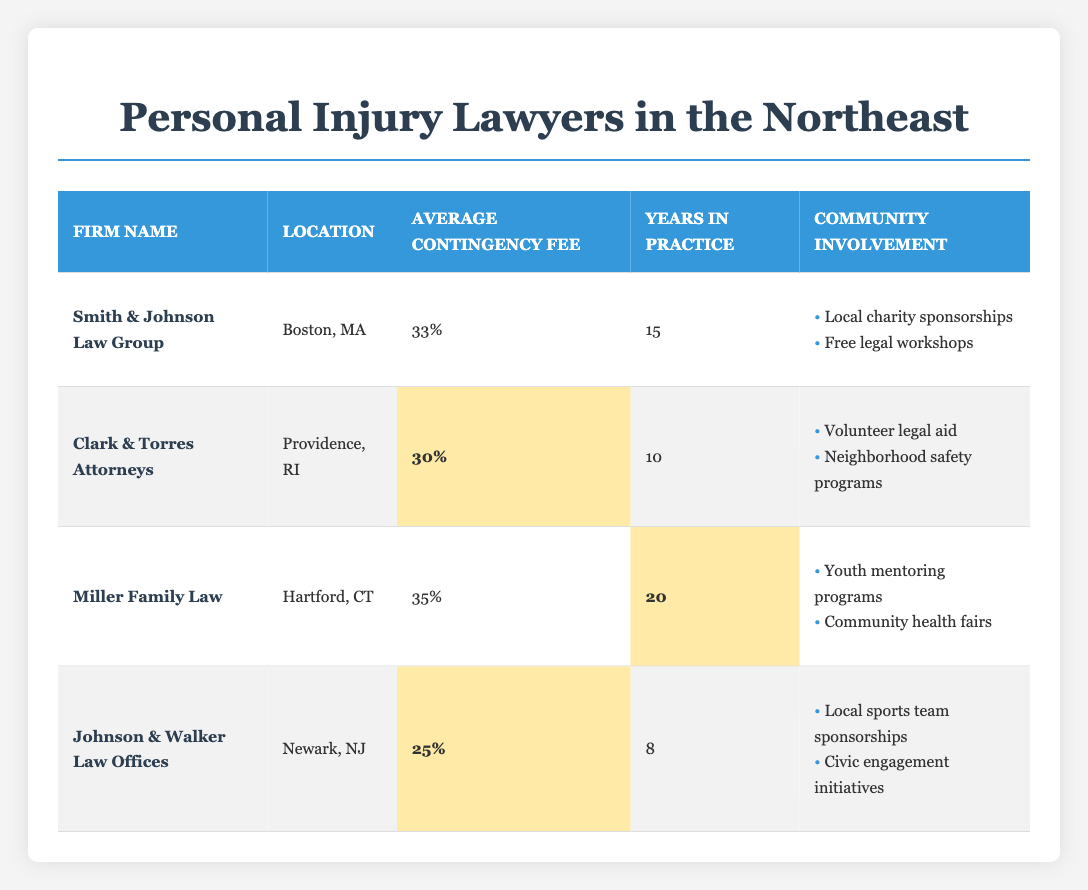What is the average contingency fee among the law firms listed? To find the average contingency fee, we need to add the contingency fees of all firms. They are 33%, 30%, 35%, and 25%. The sum is 33 + 30 + 35 + 25 = 123%. There are 4 firms, so we divide the total by 4: 123% / 4 = 30.75%.
Answer: 30.75% Which firm has the highest average contingency fee? The contingency fees listed are 33%, 30%, 35%, and 25%. The highest of these is 35%, which belongs to Miller Family Law.
Answer: Miller Family Law Does Johnson & Walker Law Offices have the least amount of years in practice among the firms listed? The years in practice for each firm are 15, 10, 20, and 8. Johnson & Walker Law Offices has 8 years, which is indeed the least among the listed firms.
Answer: Yes How many community involvement activities are listed for Clark & Torres Attorneys? Clark & Torres Attorneys has 2 community involvement activities, which are "Volunteer legal aid" and "Neighborhood safety programs".
Answer: 2 Is there a firm with a contingency fee lower than 30%? The listed contingency fees are 33%, 30%, 35%, and 25%. Since 25% is lower than 30%, Johnson & Walker Law Offices has a lower fee.
Answer: Yes What are the community involvement activities of Smith & Johnson Law Group? Smith & Johnson Law Group has two community involvement activities: "Local charity sponsorships" and "Free legal workshops."
Answer: Local charity sponsorships and Free legal workshops What is the difference in years of practice between Miller Family Law and Johnson & Walker Law Offices? Miller Family Law has 20 years of practice, while Johnson & Walker Law Offices has 8 years. The difference is 20 - 8 = 12 years.
Answer: 12 years Which law firm is located in Boston, MA? The firm located in Boston, MA is Smith & Johnson Law Group, as per the table.
Answer: Smith & Johnson Law Group 